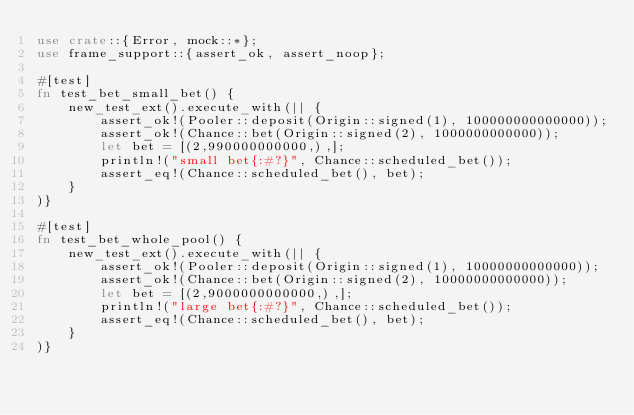Convert code to text. <code><loc_0><loc_0><loc_500><loc_500><_Rust_>use crate::{Error, mock::*};
use frame_support::{assert_ok, assert_noop};

#[test]
fn test_bet_small_bet() {
	new_test_ext().execute_with(|| {
		assert_ok!(Pooler::deposit(Origin::signed(1), 100000000000000));
		assert_ok!(Chance::bet(Origin::signed(2), 1000000000000));
		let bet = [(2,990000000000,),];
		println!("small bet{:#?}", Chance::scheduled_bet());
		assert_eq!(Chance::scheduled_bet(), bet);
	}
)}

#[test]
fn test_bet_whole_pool() {
	new_test_ext().execute_with(|| {
		assert_ok!(Pooler::deposit(Origin::signed(1), 10000000000000));
		assert_ok!(Chance::bet(Origin::signed(2), 10000000000000));
		let bet = [(2,9000000000000,),];
		println!("large bet{:#?}", Chance::scheduled_bet());
		assert_eq!(Chance::scheduled_bet(), bet);
	}
)}
</code> 